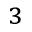Convert formula to latex. <formula><loc_0><loc_0><loc_500><loc_500>^ { 3 }</formula> 